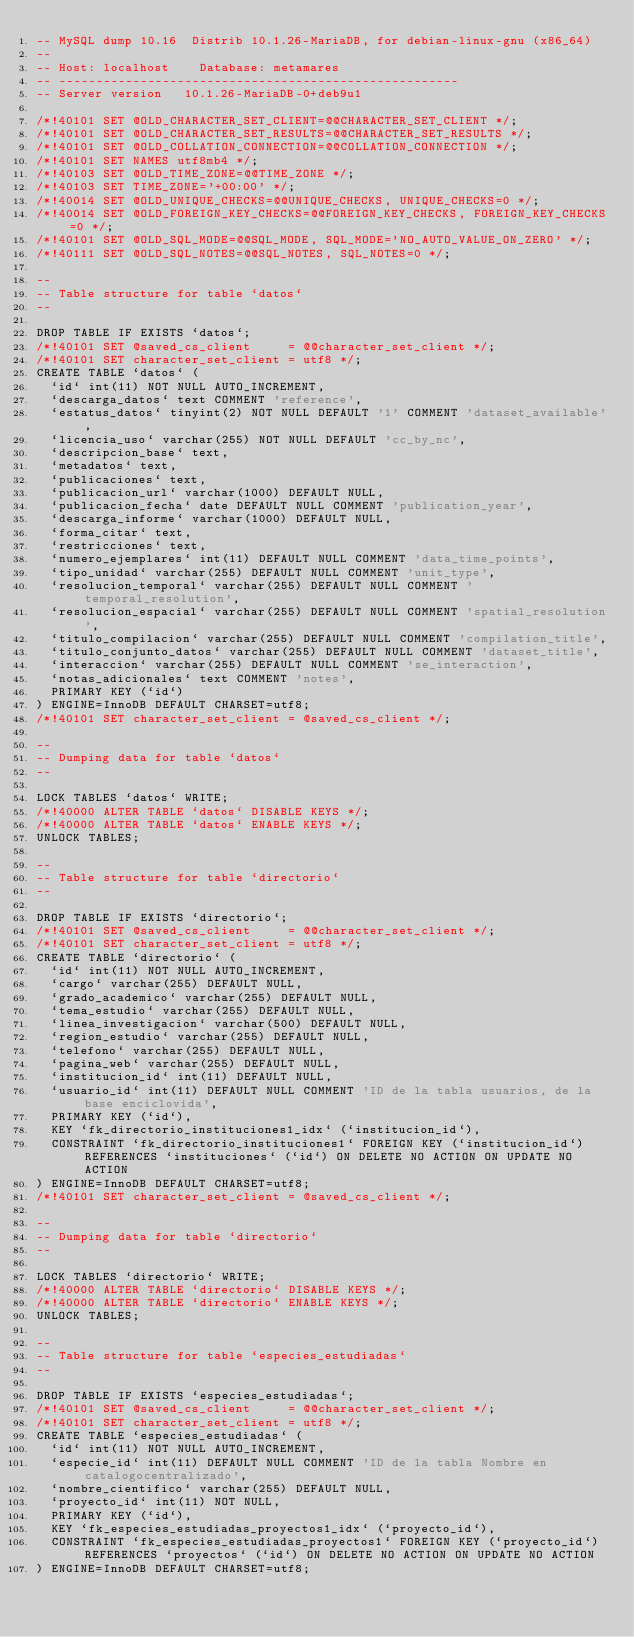<code> <loc_0><loc_0><loc_500><loc_500><_SQL_>-- MySQL dump 10.16  Distrib 10.1.26-MariaDB, for debian-linux-gnu (x86_64)
--
-- Host: localhost    Database: metamares
-- ------------------------------------------------------
-- Server version	10.1.26-MariaDB-0+deb9u1

/*!40101 SET @OLD_CHARACTER_SET_CLIENT=@@CHARACTER_SET_CLIENT */;
/*!40101 SET @OLD_CHARACTER_SET_RESULTS=@@CHARACTER_SET_RESULTS */;
/*!40101 SET @OLD_COLLATION_CONNECTION=@@COLLATION_CONNECTION */;
/*!40101 SET NAMES utf8mb4 */;
/*!40103 SET @OLD_TIME_ZONE=@@TIME_ZONE */;
/*!40103 SET TIME_ZONE='+00:00' */;
/*!40014 SET @OLD_UNIQUE_CHECKS=@@UNIQUE_CHECKS, UNIQUE_CHECKS=0 */;
/*!40014 SET @OLD_FOREIGN_KEY_CHECKS=@@FOREIGN_KEY_CHECKS, FOREIGN_KEY_CHECKS=0 */;
/*!40101 SET @OLD_SQL_MODE=@@SQL_MODE, SQL_MODE='NO_AUTO_VALUE_ON_ZERO' */;
/*!40111 SET @OLD_SQL_NOTES=@@SQL_NOTES, SQL_NOTES=0 */;

--
-- Table structure for table `datos`
--

DROP TABLE IF EXISTS `datos`;
/*!40101 SET @saved_cs_client     = @@character_set_client */;
/*!40101 SET character_set_client = utf8 */;
CREATE TABLE `datos` (
  `id` int(11) NOT NULL AUTO_INCREMENT,
  `descarga_datos` text COMMENT 'reference',
  `estatus_datos` tinyint(2) NOT NULL DEFAULT '1' COMMENT 'dataset_available',
  `licencia_uso` varchar(255) NOT NULL DEFAULT 'cc_by_nc',
  `descripcion_base` text,
  `metadatos` text,
  `publicaciones` text,
  `publicacion_url` varchar(1000) DEFAULT NULL,
  `publicacion_fecha` date DEFAULT NULL COMMENT 'publication_year',
  `descarga_informe` varchar(1000) DEFAULT NULL,
  `forma_citar` text,
  `restricciones` text,
  `numero_ejemplares` int(11) DEFAULT NULL COMMENT 'data_time_points',
  `tipo_unidad` varchar(255) DEFAULT NULL COMMENT 'unit_type',
  `resolucion_temporal` varchar(255) DEFAULT NULL COMMENT 'temporal_resolution',
  `resolucion_espacial` varchar(255) DEFAULT NULL COMMENT 'spatial_resolution',
  `titulo_compilacion` varchar(255) DEFAULT NULL COMMENT 'compilation_title',
  `titulo_conjunto_datos` varchar(255) DEFAULT NULL COMMENT 'dataset_title',
  `interaccion` varchar(255) DEFAULT NULL COMMENT 'se_interaction',
  `notas_adicionales` text COMMENT 'notes',
  PRIMARY KEY (`id`)
) ENGINE=InnoDB DEFAULT CHARSET=utf8;
/*!40101 SET character_set_client = @saved_cs_client */;

--
-- Dumping data for table `datos`
--

LOCK TABLES `datos` WRITE;
/*!40000 ALTER TABLE `datos` DISABLE KEYS */;
/*!40000 ALTER TABLE `datos` ENABLE KEYS */;
UNLOCK TABLES;

--
-- Table structure for table `directorio`
--

DROP TABLE IF EXISTS `directorio`;
/*!40101 SET @saved_cs_client     = @@character_set_client */;
/*!40101 SET character_set_client = utf8 */;
CREATE TABLE `directorio` (
  `id` int(11) NOT NULL AUTO_INCREMENT,
  `cargo` varchar(255) DEFAULT NULL,
  `grado_academico` varchar(255) DEFAULT NULL,
  `tema_estudio` varchar(255) DEFAULT NULL,
  `linea_investigacion` varchar(500) DEFAULT NULL,
  `region_estudio` varchar(255) DEFAULT NULL,
  `telefono` varchar(255) DEFAULT NULL,
  `pagina_web` varchar(255) DEFAULT NULL,
  `institucion_id` int(11) DEFAULT NULL,
  `usuario_id` int(11) DEFAULT NULL COMMENT 'ID de la tabla usuarios, de la base enciclovida',
  PRIMARY KEY (`id`),
  KEY `fk_directorio_instituciones1_idx` (`institucion_id`),
  CONSTRAINT `fk_directorio_instituciones1` FOREIGN KEY (`institucion_id`) REFERENCES `instituciones` (`id`) ON DELETE NO ACTION ON UPDATE NO ACTION
) ENGINE=InnoDB DEFAULT CHARSET=utf8;
/*!40101 SET character_set_client = @saved_cs_client */;

--
-- Dumping data for table `directorio`
--

LOCK TABLES `directorio` WRITE;
/*!40000 ALTER TABLE `directorio` DISABLE KEYS */;
/*!40000 ALTER TABLE `directorio` ENABLE KEYS */;
UNLOCK TABLES;

--
-- Table structure for table `especies_estudiadas`
--

DROP TABLE IF EXISTS `especies_estudiadas`;
/*!40101 SET @saved_cs_client     = @@character_set_client */;
/*!40101 SET character_set_client = utf8 */;
CREATE TABLE `especies_estudiadas` (
  `id` int(11) NOT NULL AUTO_INCREMENT,
  `especie_id` int(11) DEFAULT NULL COMMENT 'ID de la tabla Nombre en catalogocentralizado',
  `nombre_cientifico` varchar(255) DEFAULT NULL,
  `proyecto_id` int(11) NOT NULL,
  PRIMARY KEY (`id`),
  KEY `fk_especies_estudiadas_proyectos1_idx` (`proyecto_id`),
  CONSTRAINT `fk_especies_estudiadas_proyectos1` FOREIGN KEY (`proyecto_id`) REFERENCES `proyectos` (`id`) ON DELETE NO ACTION ON UPDATE NO ACTION
) ENGINE=InnoDB DEFAULT CHARSET=utf8;</code> 